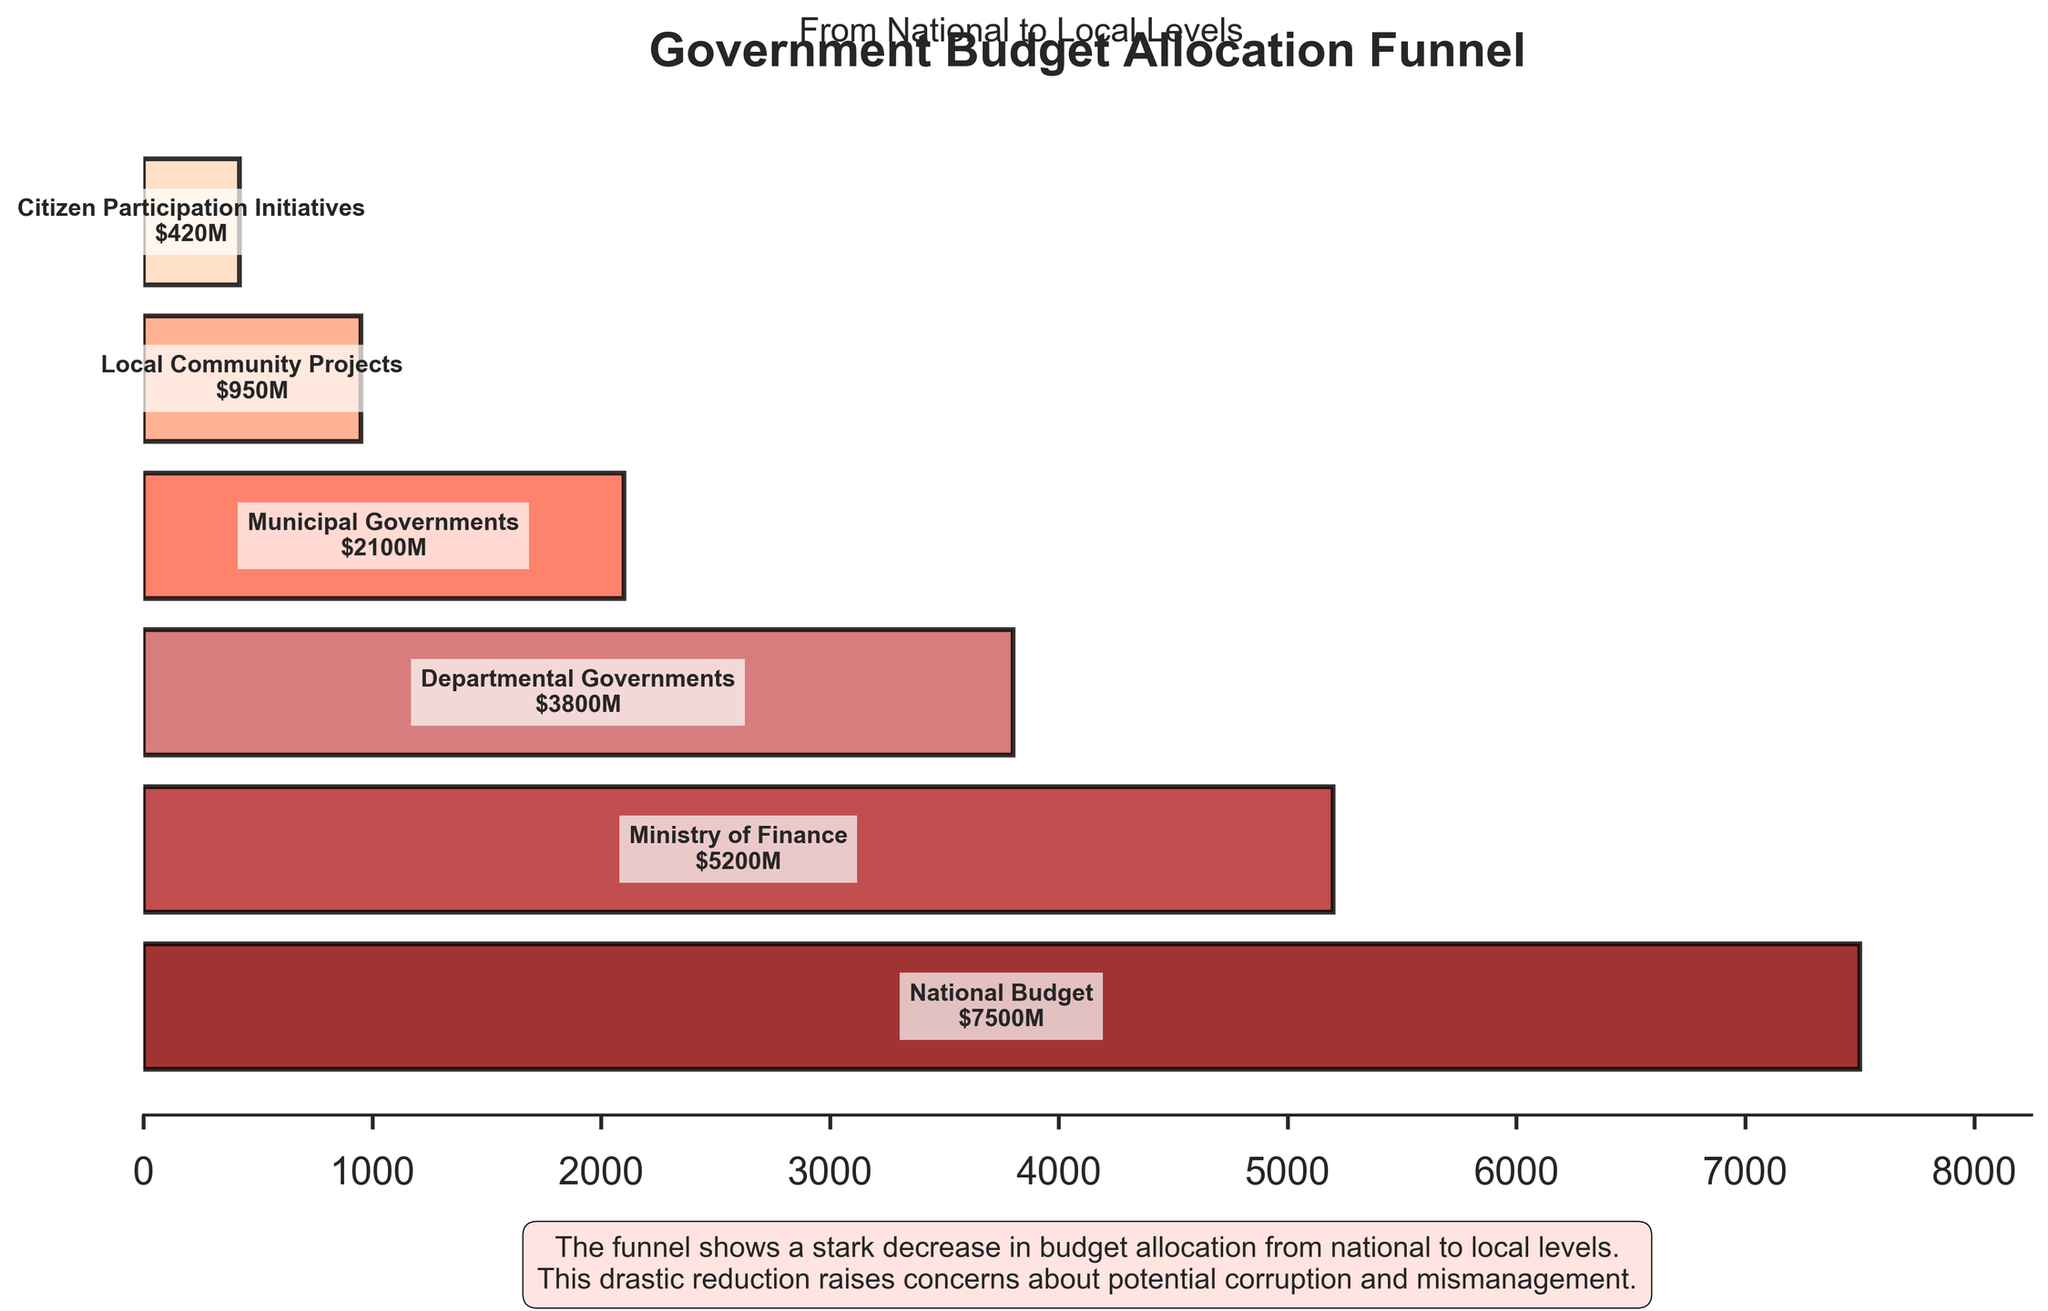What's the title of the chart? The title of the chart is displayed at the top of the figure.
Answer: Government Budget Allocation Funnel How many stages are depicted in the chart? Count the number of different stages listed on the y-axis bars in the chart.
Answer: 6 Which stage has the highest allocated amount? Identify the stage with the longest bar as it represents the highest amount.
Answer: National Budget What is the total reduction from the National Budget to Local Community Projects? Subtract the amount allocated to Local Community Projects from the National Budget amount: 7500 - 950.
Answer: 6550 Which stage experiences the largest drop in allocation from the previous stage? Compare the differences between successive stages and identify the largest drop: National Budget to Ministry of Finance (2300), Ministry of Finance to Departmental Governments (1400), Departmental Governments to Municipal Governments (1700), Municipal Governments to Local Community Projects (1150), Local Community Projects to Citizen Participation Initiatives (530).
Answer: Municipal Governments What is the approximate percentage reduction in budget from the National Budget to the Municipal Governments? Calculate the percentage reduction: ((7500 - 2100) / 7500) * 100.
Answer: Approximately 72% How much more funding does the Ministry of Finance receive compared to the Local Community Projects? Subtract the amount allocated to Local Community Projects from the Ministry of Finance amount: 5200 - 950.
Answer: 4250 What's the average budget allocated across all stages? Calculate the total sum of all amounts and divide it by the number of stages: (7500 + 5200 + 3800 + 2100 + 950 + 420) / 6.
Answer: 3328.33 Which stages receive less than 1000 million USD? Identify the stages with amounts less than 1000 million USD.
Answer: Local Community Projects, Citizen Participation Initiatives How does the commentary describe the budget reduction from national to local levels? Refer to the text in the commentary box at the bottom of the chart.
Answer: Drastic reduction raises concerns about potential corruption and mismanagement 